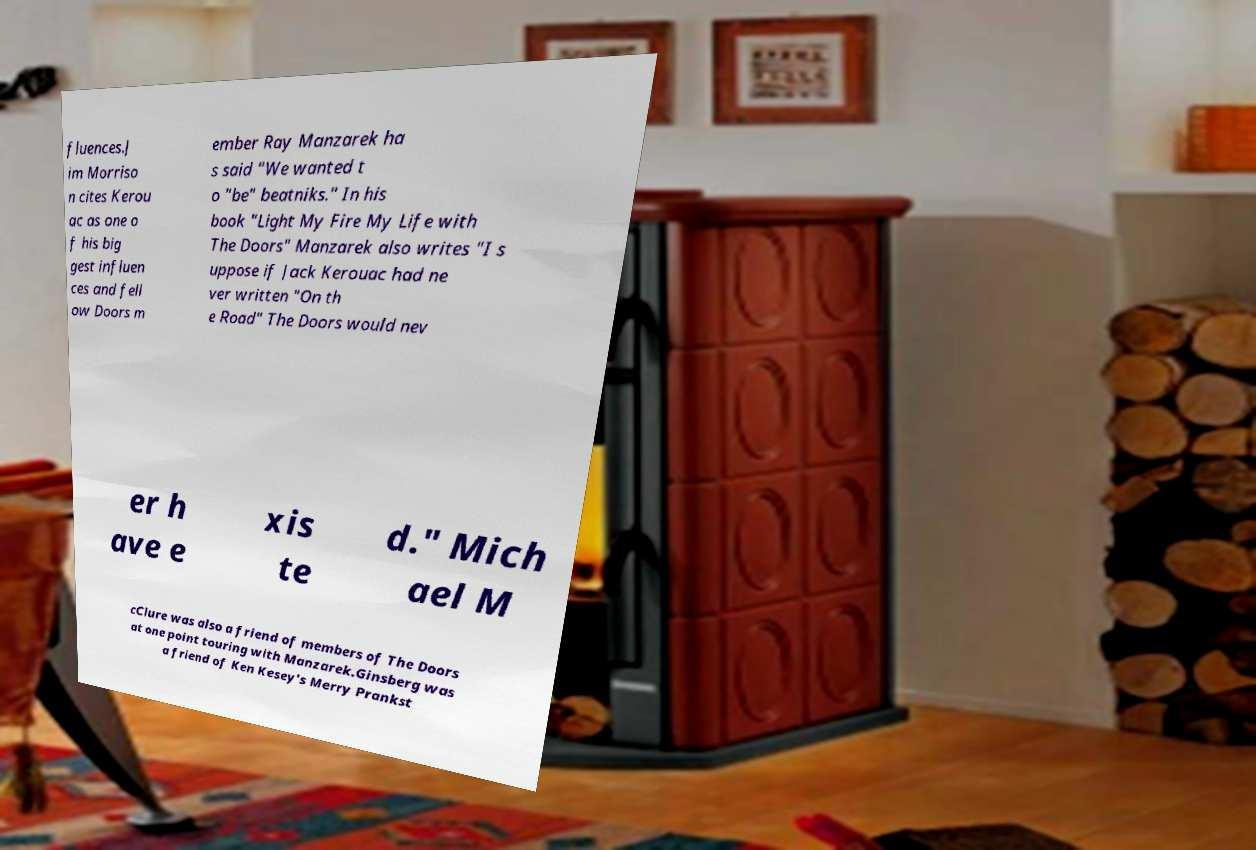Can you accurately transcribe the text from the provided image for me? fluences.J im Morriso n cites Kerou ac as one o f his big gest influen ces and fell ow Doors m ember Ray Manzarek ha s said "We wanted t o "be" beatniks." In his book "Light My Fire My Life with The Doors" Manzarek also writes "I s uppose if Jack Kerouac had ne ver written "On th e Road" The Doors would nev er h ave e xis te d." Mich ael M cClure was also a friend of members of The Doors at one point touring with Manzarek.Ginsberg was a friend of Ken Kesey's Merry Prankst 